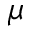Convert formula to latex. <formula><loc_0><loc_0><loc_500><loc_500>\mu</formula> 